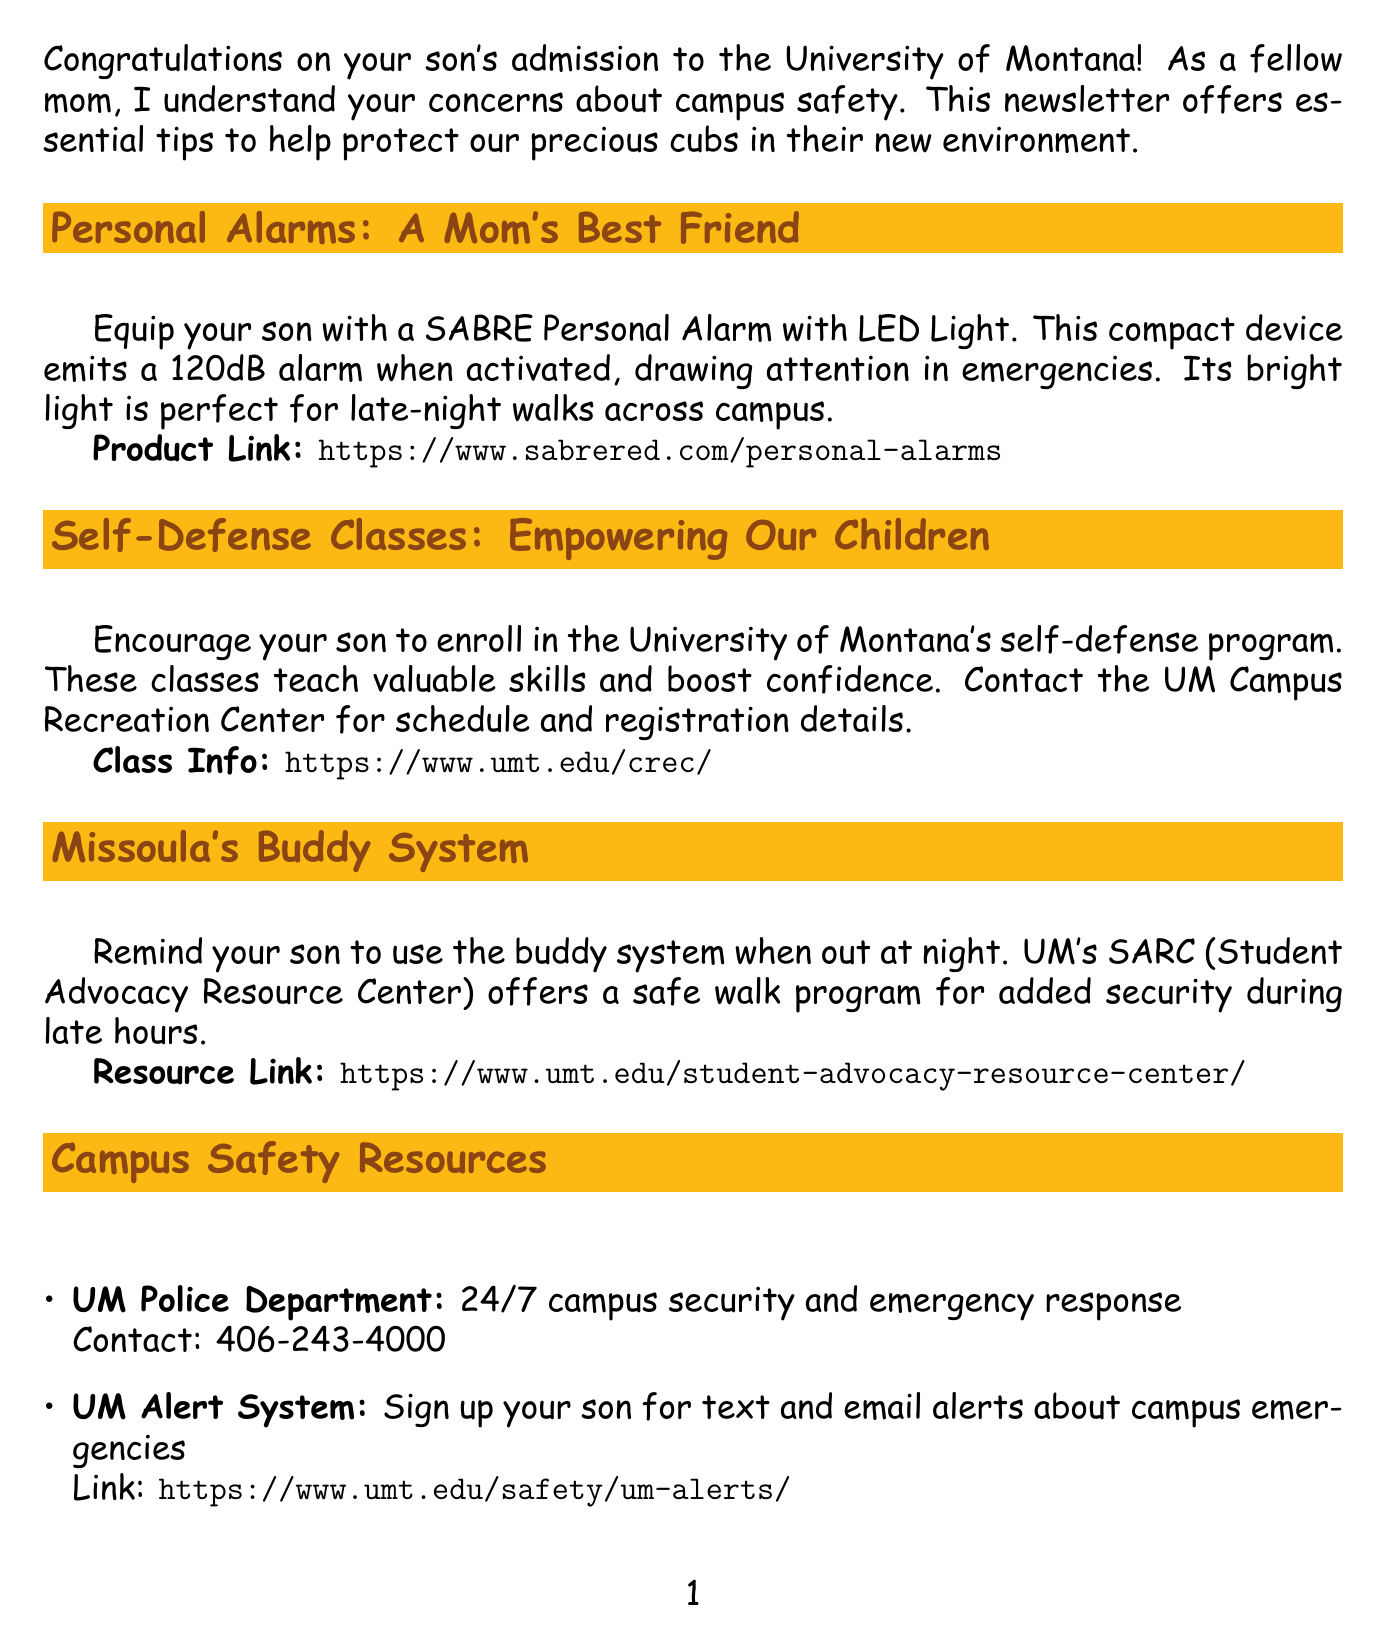what is the title of the newsletter? The title of the newsletter is stated at the beginning, introducing the theme of safety for mothers.
Answer: Keeping Your Montana Grizzly Safe: A Mother's Guide to College Safety what personal alarm is recommended? The document suggests a specific product to keep your son safe.
Answer: SABRE Personal Alarm with LED Light how loud is the SABRE Personal Alarm? The loudness of the alarm is mentioned in the description of the product.
Answer: 120dB where can your son enroll in self-defense classes? The document provides a resource for self-defense classes offered at the University.
Answer: UM Campus Recreation Center what should your son use when out at night? The newsletter advises on a social safety practice to enhance security.
Answer: Buddy system what is the contact number for the UM Police Department? This information is provided in the campus safety resources section.
Answer: 406-243-4000 what does the UM Alert System provide? The alert system's function is described in the resources section of the newsletter.
Answer: Text and email alerts about campus emergencies what should parents program in their son's phone? This advice is directed towards smartphone safety and preparedness.
Answer: Important numbers how can your son stay safe at parties? A specific risk is highlighted in the mom-to-mom advice section.
Answer: Accepting drinks from strangers 